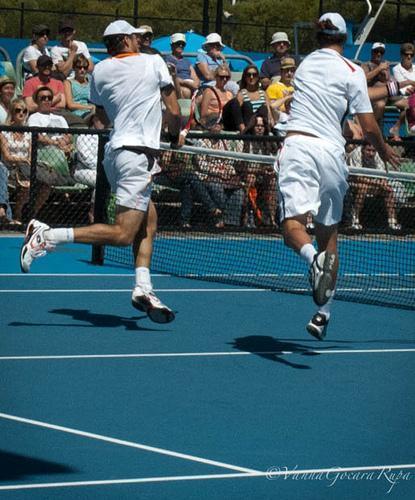How many people total are probably playing this game?
Give a very brief answer. 4. How many people are there?
Give a very brief answer. 3. 